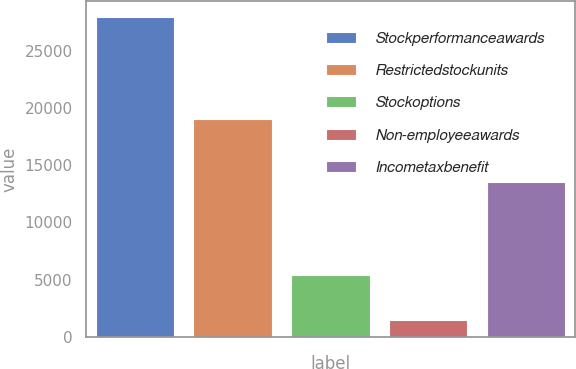<chart> <loc_0><loc_0><loc_500><loc_500><bar_chart><fcel>Stockperformanceawards<fcel>Restrictedstockunits<fcel>Stockoptions<fcel>Non-employeeawards<fcel>Incometaxbenefit<nl><fcel>27960<fcel>19052<fcel>5419<fcel>1449<fcel>13489<nl></chart> 